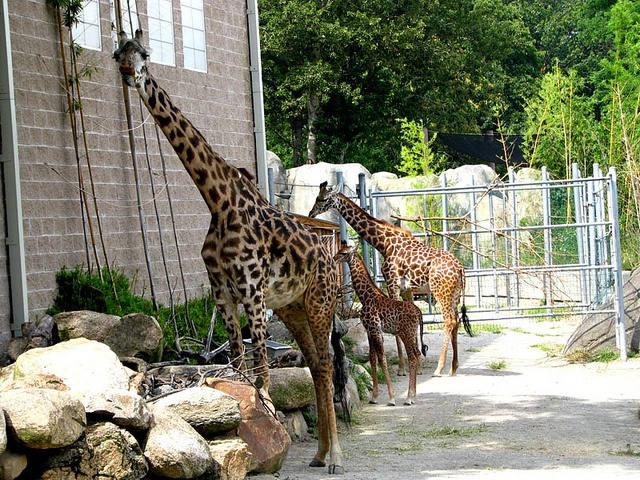Describe the objects in this image and their specific colors. I can see giraffe in gray, black, and maroon tones, giraffe in gray, ivory, black, and tan tones, and giraffe in gray, black, and maroon tones in this image. 